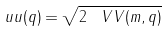<formula> <loc_0><loc_0><loc_500><loc_500>\ u u ( q ) = \sqrt { 2 \, \ V V ( m , q ) }</formula> 